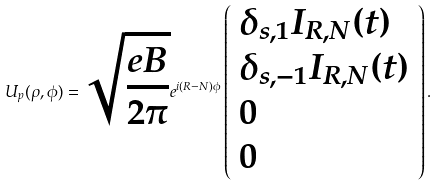Convert formula to latex. <formula><loc_0><loc_0><loc_500><loc_500>U _ { p } ( \rho , \phi ) = \sqrt { \frac { e B } { 2 \pi } } e ^ { i ( R - N ) \phi } \left ( \begin{array} { l } \delta _ { s , 1 } I _ { R , N } ( t ) \\ \delta _ { s , - 1 } I _ { R , N } ( t ) \\ 0 \\ 0 \\ \end{array} \right ) .</formula> 